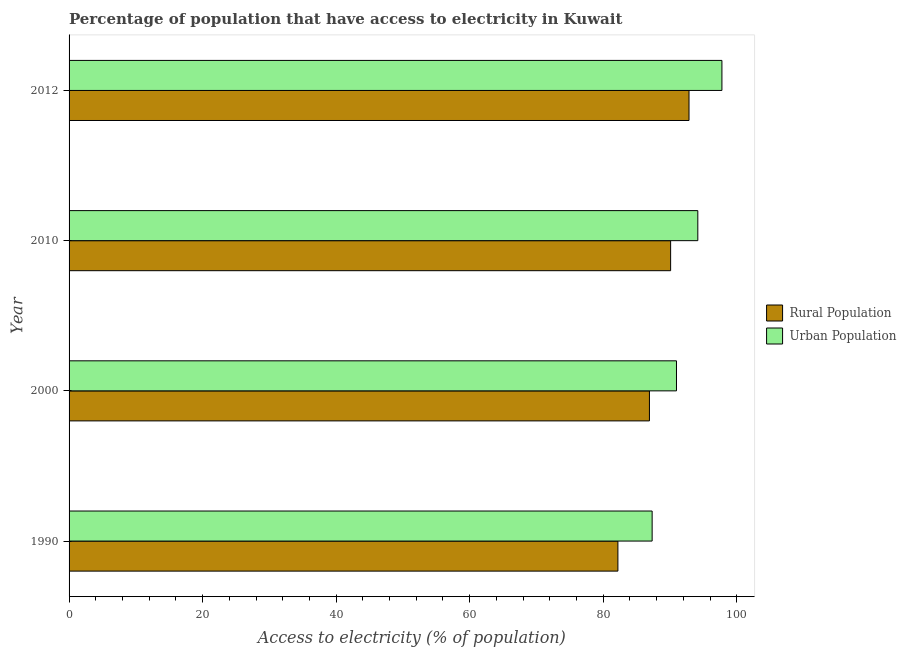How many different coloured bars are there?
Your answer should be compact. 2. Are the number of bars per tick equal to the number of legend labels?
Your response must be concise. Yes. Are the number of bars on each tick of the Y-axis equal?
Provide a short and direct response. Yes. What is the percentage of rural population having access to electricity in 2012?
Offer a terse response. 92.85. Across all years, what is the maximum percentage of rural population having access to electricity?
Make the answer very short. 92.85. Across all years, what is the minimum percentage of urban population having access to electricity?
Make the answer very short. 87.33. In which year was the percentage of rural population having access to electricity maximum?
Provide a succinct answer. 2012. What is the total percentage of urban population having access to electricity in the graph?
Your answer should be very brief. 370.26. What is the difference between the percentage of urban population having access to electricity in 2000 and that in 2012?
Give a very brief answer. -6.81. What is the difference between the percentage of rural population having access to electricity in 2000 and the percentage of urban population having access to electricity in 2010?
Give a very brief answer. -7.25. What is the average percentage of rural population having access to electricity per year?
Provide a short and direct response. 88.02. In the year 2010, what is the difference between the percentage of urban population having access to electricity and percentage of rural population having access to electricity?
Keep it short and to the point. 4.07. What is the ratio of the percentage of rural population having access to electricity in 1990 to that in 2012?
Your response must be concise. 0.89. Is the percentage of urban population having access to electricity in 1990 less than that in 2010?
Ensure brevity in your answer.  Yes. Is the difference between the percentage of urban population having access to electricity in 1990 and 2000 greater than the difference between the percentage of rural population having access to electricity in 1990 and 2000?
Provide a short and direct response. Yes. What is the difference between the highest and the second highest percentage of urban population having access to electricity?
Your response must be concise. 3.61. What is the difference between the highest and the lowest percentage of rural population having access to electricity?
Offer a very short reply. 10.65. In how many years, is the percentage of urban population having access to electricity greater than the average percentage of urban population having access to electricity taken over all years?
Provide a short and direct response. 2. Is the sum of the percentage of urban population having access to electricity in 2000 and 2010 greater than the maximum percentage of rural population having access to electricity across all years?
Keep it short and to the point. Yes. What does the 2nd bar from the top in 2000 represents?
Your answer should be very brief. Rural Population. What does the 2nd bar from the bottom in 2010 represents?
Provide a short and direct response. Urban Population. Are the values on the major ticks of X-axis written in scientific E-notation?
Keep it short and to the point. No. Does the graph contain grids?
Your response must be concise. No. How are the legend labels stacked?
Your response must be concise. Vertical. What is the title of the graph?
Offer a very short reply. Percentage of population that have access to electricity in Kuwait. Does "Goods and services" appear as one of the legend labels in the graph?
Your answer should be very brief. No. What is the label or title of the X-axis?
Keep it short and to the point. Access to electricity (% of population). What is the label or title of the Y-axis?
Ensure brevity in your answer.  Year. What is the Access to electricity (% of population) of Rural Population in 1990?
Provide a short and direct response. 82.2. What is the Access to electricity (% of population) of Urban Population in 1990?
Your response must be concise. 87.33. What is the Access to electricity (% of population) in Rural Population in 2000?
Your answer should be very brief. 86.93. What is the Access to electricity (% of population) in Urban Population in 2000?
Your answer should be very brief. 90.98. What is the Access to electricity (% of population) of Rural Population in 2010?
Offer a terse response. 90.1. What is the Access to electricity (% of population) in Urban Population in 2010?
Ensure brevity in your answer.  94.17. What is the Access to electricity (% of population) in Rural Population in 2012?
Your answer should be very brief. 92.85. What is the Access to electricity (% of population) of Urban Population in 2012?
Keep it short and to the point. 97.78. Across all years, what is the maximum Access to electricity (% of population) in Rural Population?
Give a very brief answer. 92.85. Across all years, what is the maximum Access to electricity (% of population) in Urban Population?
Give a very brief answer. 97.78. Across all years, what is the minimum Access to electricity (% of population) of Rural Population?
Provide a succinct answer. 82.2. Across all years, what is the minimum Access to electricity (% of population) of Urban Population?
Your response must be concise. 87.33. What is the total Access to electricity (% of population) of Rural Population in the graph?
Offer a terse response. 352.08. What is the total Access to electricity (% of population) in Urban Population in the graph?
Offer a very short reply. 370.26. What is the difference between the Access to electricity (% of population) of Rural Population in 1990 and that in 2000?
Your answer should be very brief. -4.72. What is the difference between the Access to electricity (% of population) of Urban Population in 1990 and that in 2000?
Your answer should be compact. -3.64. What is the difference between the Access to electricity (% of population) of Rural Population in 1990 and that in 2010?
Keep it short and to the point. -7.9. What is the difference between the Access to electricity (% of population) of Urban Population in 1990 and that in 2010?
Make the answer very short. -6.84. What is the difference between the Access to electricity (% of population) of Rural Population in 1990 and that in 2012?
Give a very brief answer. -10.65. What is the difference between the Access to electricity (% of population) of Urban Population in 1990 and that in 2012?
Keep it short and to the point. -10.45. What is the difference between the Access to electricity (% of population) of Rural Population in 2000 and that in 2010?
Your response must be concise. -3.17. What is the difference between the Access to electricity (% of population) of Urban Population in 2000 and that in 2010?
Provide a succinct answer. -3.2. What is the difference between the Access to electricity (% of population) of Rural Population in 2000 and that in 2012?
Your answer should be compact. -5.93. What is the difference between the Access to electricity (% of population) of Urban Population in 2000 and that in 2012?
Your answer should be compact. -6.81. What is the difference between the Access to electricity (% of population) in Rural Population in 2010 and that in 2012?
Your answer should be very brief. -2.75. What is the difference between the Access to electricity (% of population) of Urban Population in 2010 and that in 2012?
Your answer should be compact. -3.61. What is the difference between the Access to electricity (% of population) of Rural Population in 1990 and the Access to electricity (% of population) of Urban Population in 2000?
Offer a terse response. -8.77. What is the difference between the Access to electricity (% of population) in Rural Population in 1990 and the Access to electricity (% of population) in Urban Population in 2010?
Keep it short and to the point. -11.97. What is the difference between the Access to electricity (% of population) of Rural Population in 1990 and the Access to electricity (% of population) of Urban Population in 2012?
Your answer should be compact. -15.58. What is the difference between the Access to electricity (% of population) in Rural Population in 2000 and the Access to electricity (% of population) in Urban Population in 2010?
Your answer should be compact. -7.25. What is the difference between the Access to electricity (% of population) in Rural Population in 2000 and the Access to electricity (% of population) in Urban Population in 2012?
Your answer should be very brief. -10.86. What is the difference between the Access to electricity (% of population) in Rural Population in 2010 and the Access to electricity (% of population) in Urban Population in 2012?
Offer a very short reply. -7.68. What is the average Access to electricity (% of population) in Rural Population per year?
Your answer should be compact. 88.02. What is the average Access to electricity (% of population) in Urban Population per year?
Provide a succinct answer. 92.57. In the year 1990, what is the difference between the Access to electricity (% of population) in Rural Population and Access to electricity (% of population) in Urban Population?
Make the answer very short. -5.13. In the year 2000, what is the difference between the Access to electricity (% of population) of Rural Population and Access to electricity (% of population) of Urban Population?
Keep it short and to the point. -4.05. In the year 2010, what is the difference between the Access to electricity (% of population) of Rural Population and Access to electricity (% of population) of Urban Population?
Your response must be concise. -4.07. In the year 2012, what is the difference between the Access to electricity (% of population) of Rural Population and Access to electricity (% of population) of Urban Population?
Keep it short and to the point. -4.93. What is the ratio of the Access to electricity (% of population) in Rural Population in 1990 to that in 2000?
Provide a succinct answer. 0.95. What is the ratio of the Access to electricity (% of population) in Urban Population in 1990 to that in 2000?
Make the answer very short. 0.96. What is the ratio of the Access to electricity (% of population) of Rural Population in 1990 to that in 2010?
Give a very brief answer. 0.91. What is the ratio of the Access to electricity (% of population) in Urban Population in 1990 to that in 2010?
Provide a succinct answer. 0.93. What is the ratio of the Access to electricity (% of population) in Rural Population in 1990 to that in 2012?
Offer a terse response. 0.89. What is the ratio of the Access to electricity (% of population) in Urban Population in 1990 to that in 2012?
Offer a terse response. 0.89. What is the ratio of the Access to electricity (% of population) in Rural Population in 2000 to that in 2010?
Ensure brevity in your answer.  0.96. What is the ratio of the Access to electricity (% of population) of Urban Population in 2000 to that in 2010?
Your response must be concise. 0.97. What is the ratio of the Access to electricity (% of population) of Rural Population in 2000 to that in 2012?
Keep it short and to the point. 0.94. What is the ratio of the Access to electricity (% of population) in Urban Population in 2000 to that in 2012?
Your response must be concise. 0.93. What is the ratio of the Access to electricity (% of population) in Rural Population in 2010 to that in 2012?
Your response must be concise. 0.97. What is the ratio of the Access to electricity (% of population) in Urban Population in 2010 to that in 2012?
Offer a very short reply. 0.96. What is the difference between the highest and the second highest Access to electricity (% of population) in Rural Population?
Ensure brevity in your answer.  2.75. What is the difference between the highest and the second highest Access to electricity (% of population) of Urban Population?
Ensure brevity in your answer.  3.61. What is the difference between the highest and the lowest Access to electricity (% of population) in Rural Population?
Make the answer very short. 10.65. What is the difference between the highest and the lowest Access to electricity (% of population) in Urban Population?
Offer a terse response. 10.45. 